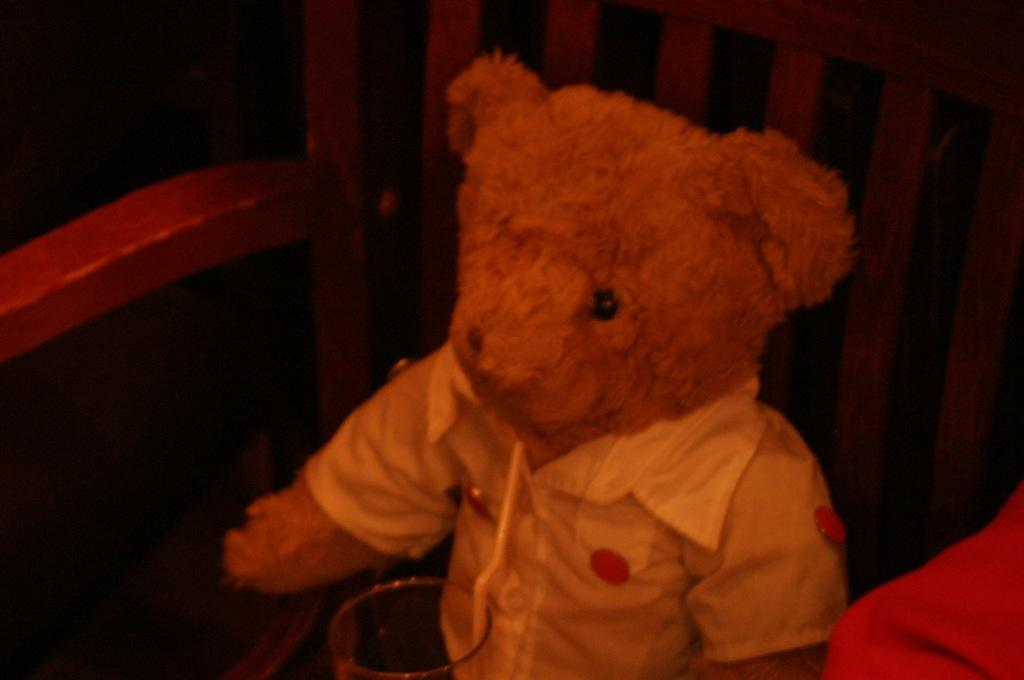What type of toy is present in the image? There is a teddy bear in the image. Whose hand is visible in the image? A person's hand is visible in the image. What object is used for storage in the image? There is a container in the image. What feature is present for entering or exiting a space in the image? There is a door in the image. What structure is present for enclosing or separating areas in the image? There is a fence in the image. Can you describe the setting where the image was taken? The image may have been taken in a room, based on the presence of a door and the possible presence of a wall. Are there any poisonous substances visible in the image? There is no mention of poisonous substances in the image, so it cannot be determined from the provided facts. What type of sack is being used to carry the teddy bear in the image? There is no sack present in the image, and the teddy bear is not being carried by any visible object. 